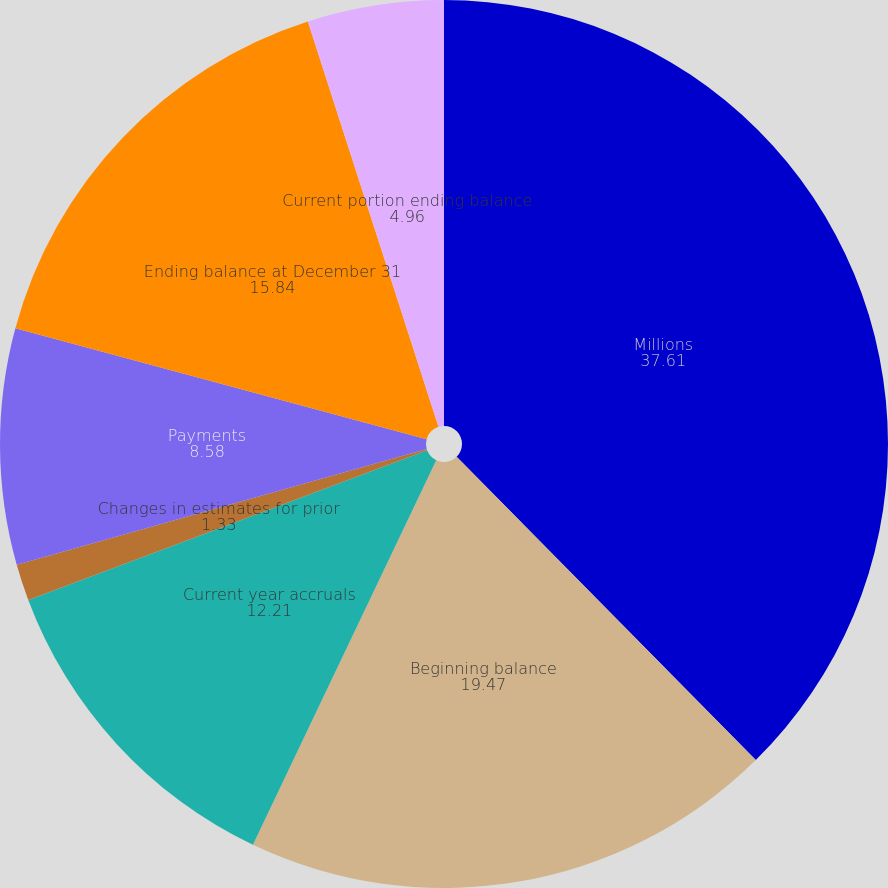<chart> <loc_0><loc_0><loc_500><loc_500><pie_chart><fcel>Millions<fcel>Beginning balance<fcel>Current year accruals<fcel>Changes in estimates for prior<fcel>Payments<fcel>Ending balance at December 31<fcel>Current portion ending balance<nl><fcel>37.61%<fcel>19.47%<fcel>12.21%<fcel>1.33%<fcel>8.58%<fcel>15.84%<fcel>4.96%<nl></chart> 